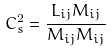Convert formula to latex. <formula><loc_0><loc_0><loc_500><loc_500>C _ { s } ^ { 2 } = \frac { L _ { i j } M _ { i j } } { M _ { i j } M _ { i j } }</formula> 